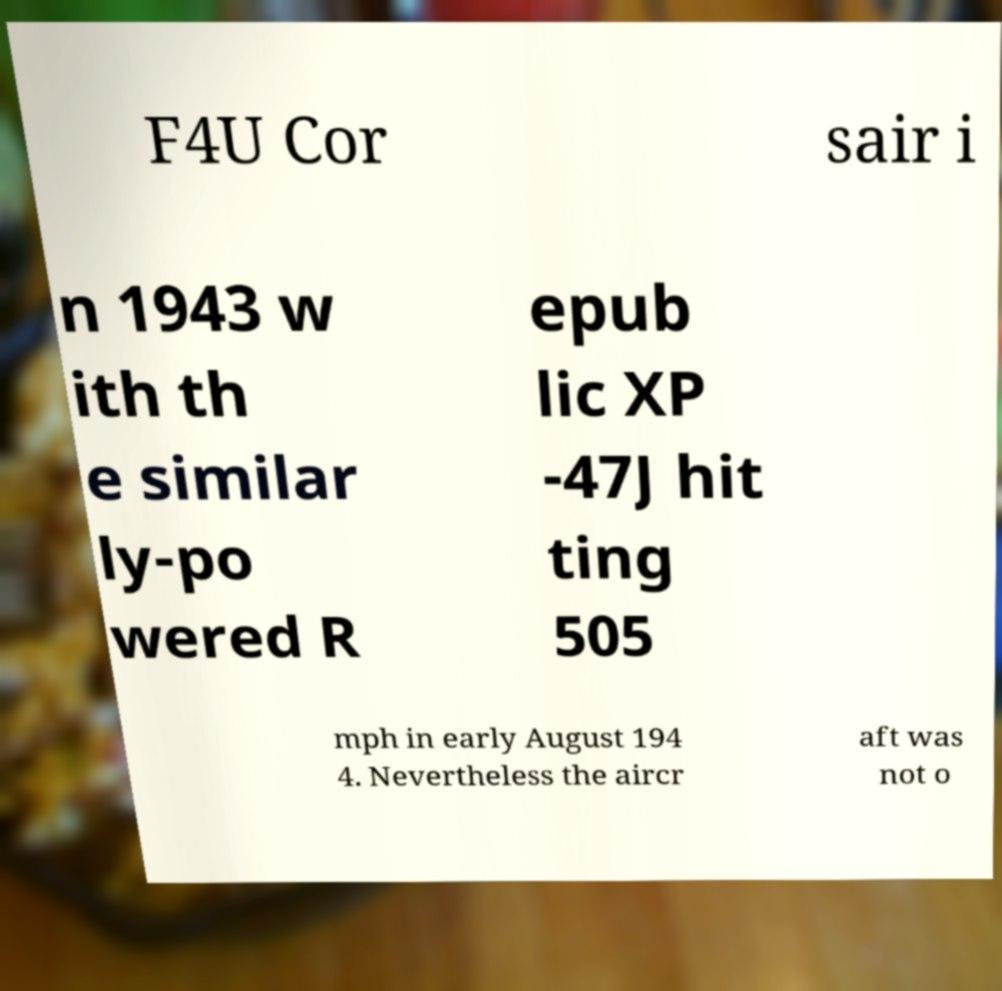Could you assist in decoding the text presented in this image and type it out clearly? F4U Cor sair i n 1943 w ith th e similar ly-po wered R epub lic XP -47J hit ting 505 mph in early August 194 4. Nevertheless the aircr aft was not o 